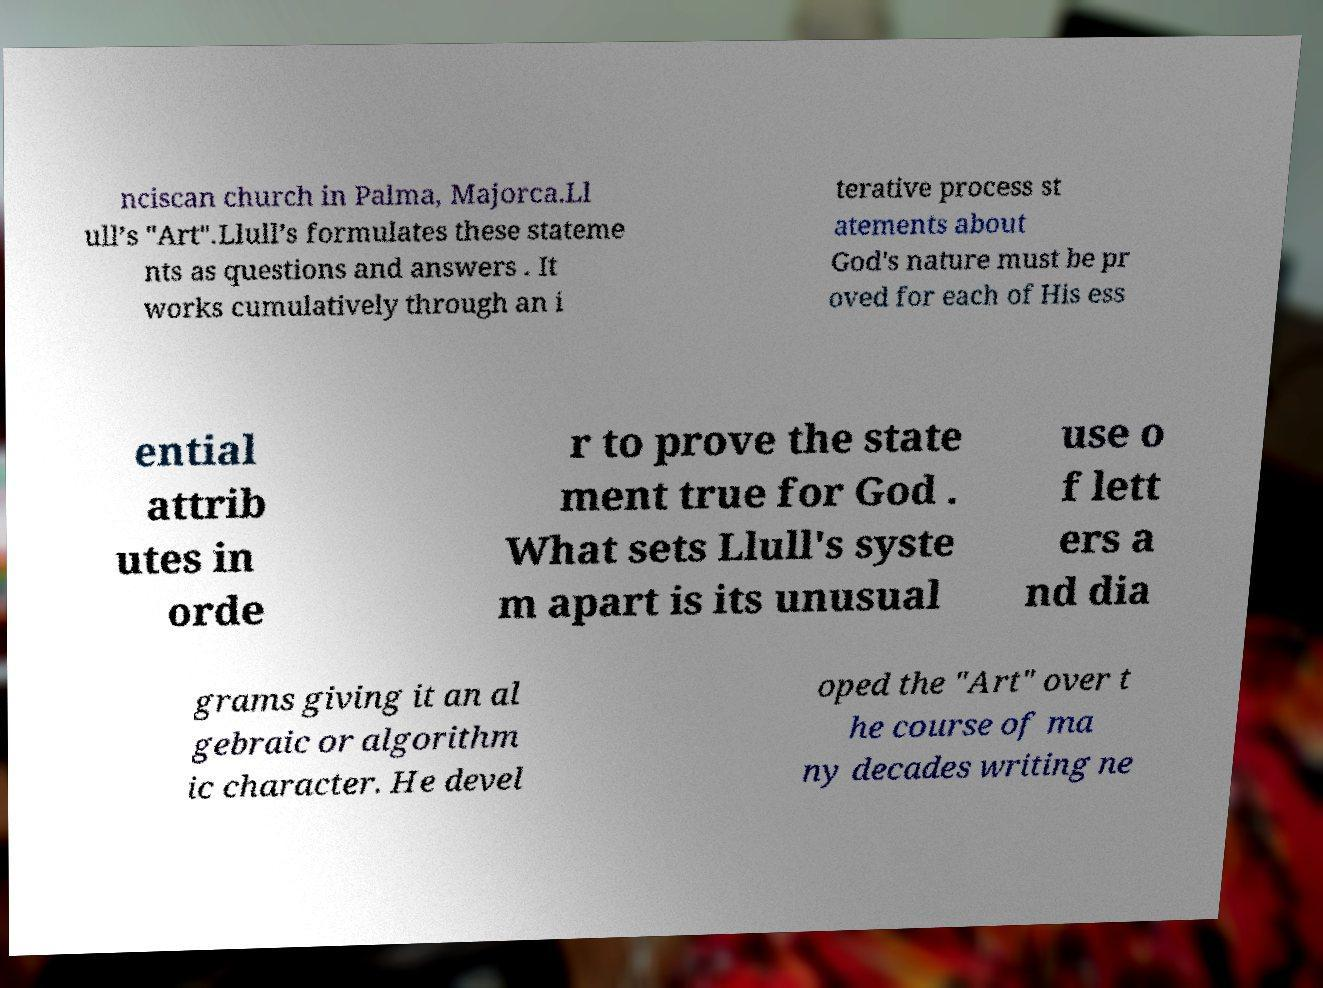Can you accurately transcribe the text from the provided image for me? nciscan church in Palma, Majorca.Ll ull’s "Art".Llull’s formulates these stateme nts as questions and answers . It works cumulatively through an i terative process st atements about God's nature must be pr oved for each of His ess ential attrib utes in orde r to prove the state ment true for God . What sets Llull's syste m apart is its unusual use o f lett ers a nd dia grams giving it an al gebraic or algorithm ic character. He devel oped the "Art" over t he course of ma ny decades writing ne 